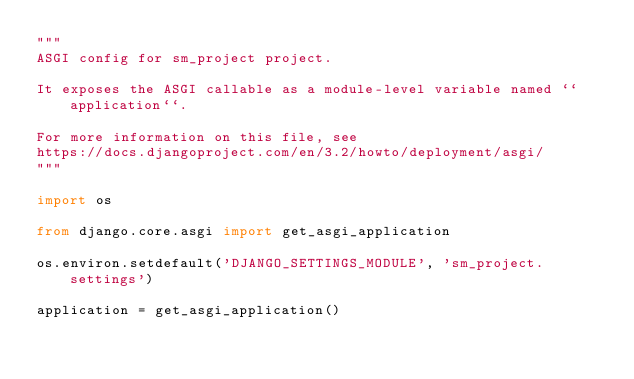Convert code to text. <code><loc_0><loc_0><loc_500><loc_500><_Python_>"""
ASGI config for sm_project project.

It exposes the ASGI callable as a module-level variable named ``application``.

For more information on this file, see
https://docs.djangoproject.com/en/3.2/howto/deployment/asgi/
"""

import os

from django.core.asgi import get_asgi_application

os.environ.setdefault('DJANGO_SETTINGS_MODULE', 'sm_project.settings')

application = get_asgi_application()
</code> 